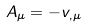Convert formula to latex. <formula><loc_0><loc_0><loc_500><loc_500>A _ { \mu } = - v _ { , \mu }</formula> 